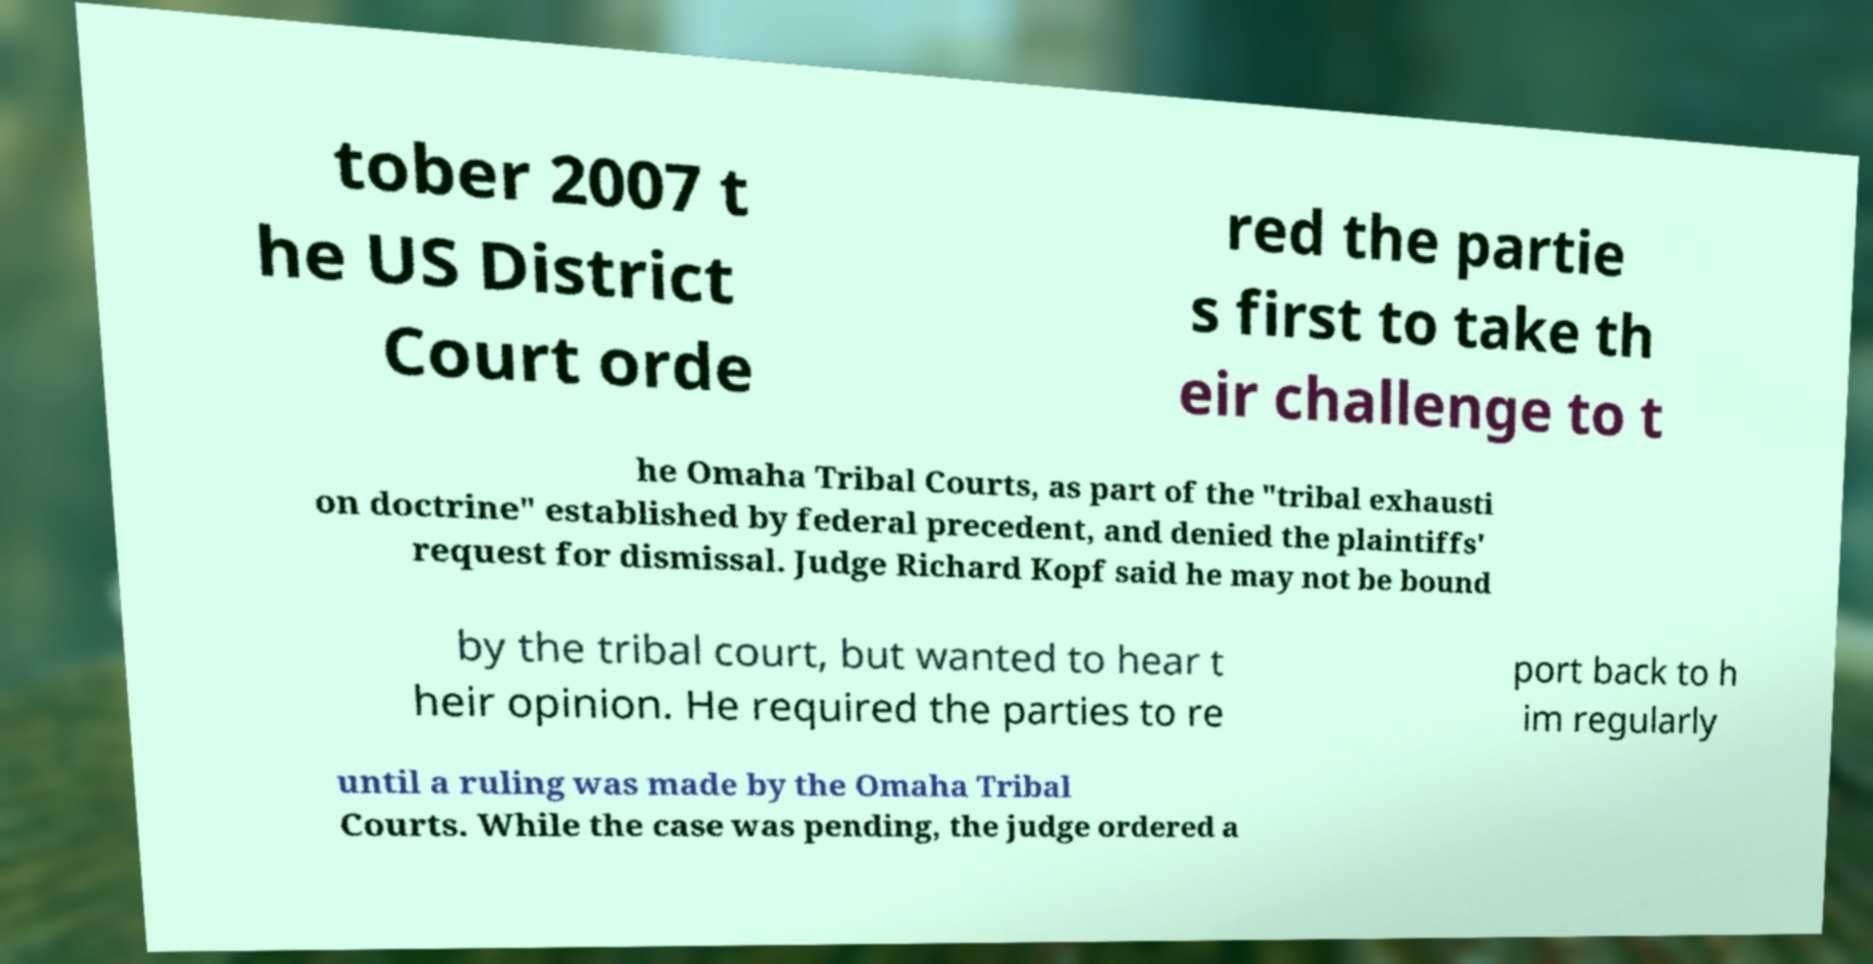What messages or text are displayed in this image? I need them in a readable, typed format. tober 2007 t he US District Court orde red the partie s first to take th eir challenge to t he Omaha Tribal Courts, as part of the "tribal exhausti on doctrine" established by federal precedent, and denied the plaintiffs' request for dismissal. Judge Richard Kopf said he may not be bound by the tribal court, but wanted to hear t heir opinion. He required the parties to re port back to h im regularly until a ruling was made by the Omaha Tribal Courts. While the case was pending, the judge ordered a 